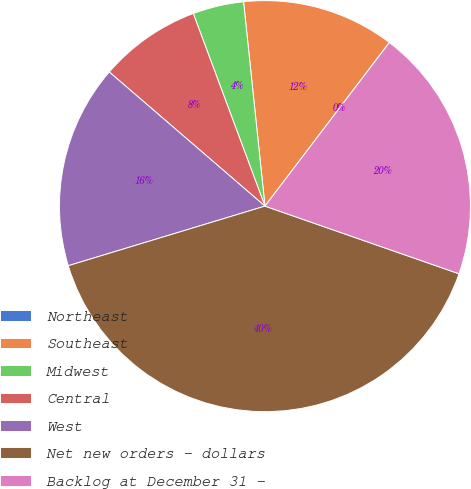Convert chart to OTSL. <chart><loc_0><loc_0><loc_500><loc_500><pie_chart><fcel>Northeast<fcel>Southeast<fcel>Midwest<fcel>Central<fcel>West<fcel>Net new orders - dollars<fcel>Backlog at December 31 -<nl><fcel>0.01%<fcel>12.0%<fcel>4.01%<fcel>8.01%<fcel>16.0%<fcel>39.98%<fcel>19.99%<nl></chart> 